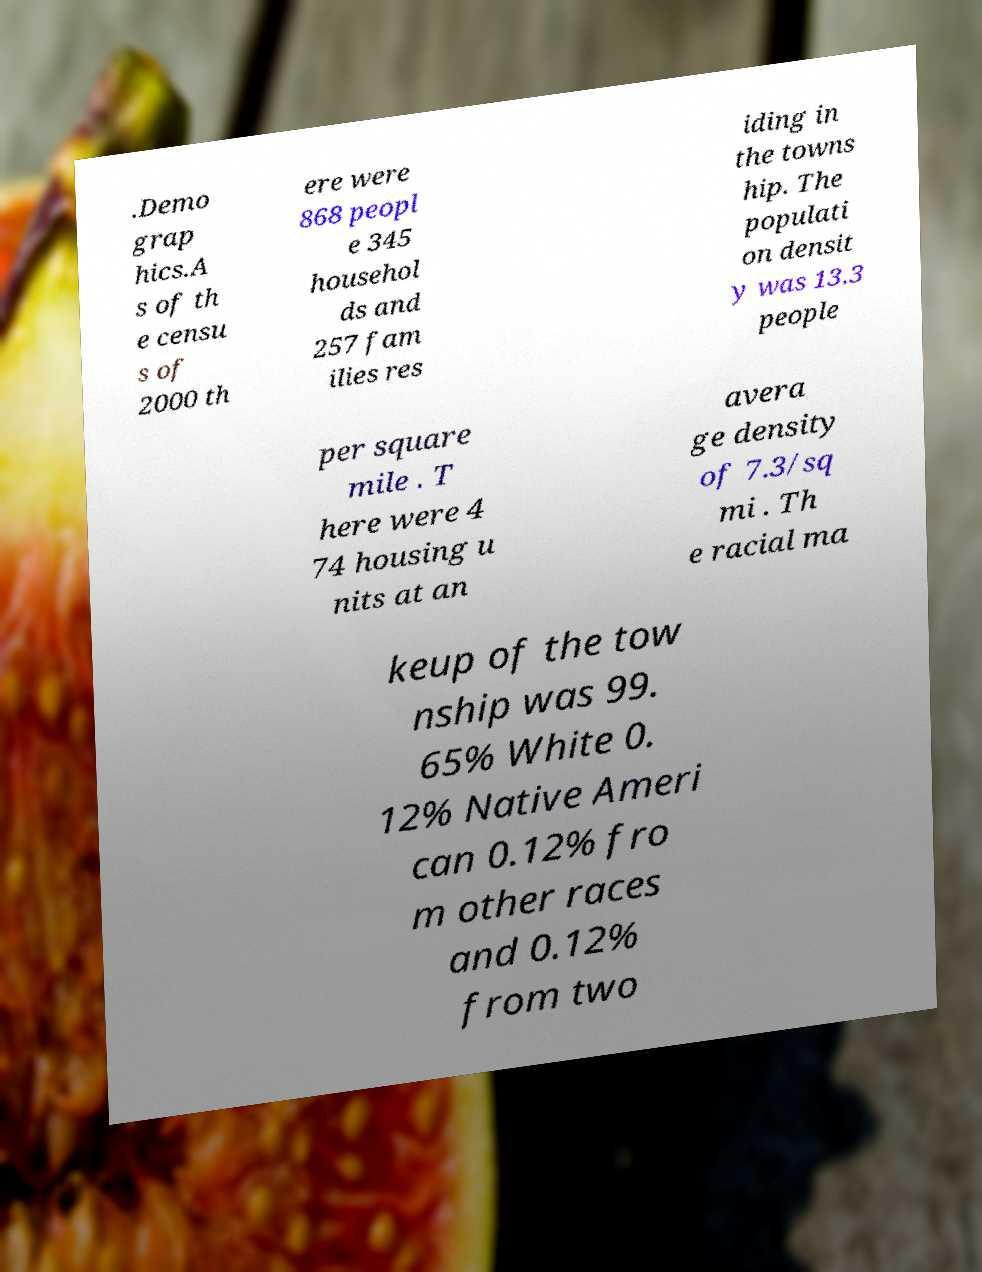For documentation purposes, I need the text within this image transcribed. Could you provide that? .Demo grap hics.A s of th e censu s of 2000 th ere were 868 peopl e 345 househol ds and 257 fam ilies res iding in the towns hip. The populati on densit y was 13.3 people per square mile . T here were 4 74 housing u nits at an avera ge density of 7.3/sq mi . Th e racial ma keup of the tow nship was 99. 65% White 0. 12% Native Ameri can 0.12% fro m other races and 0.12% from two 